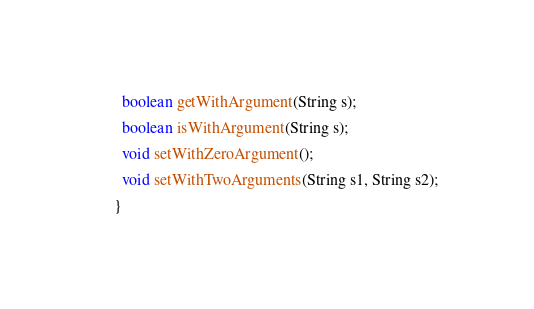<code> <loc_0><loc_0><loc_500><loc_500><_Java_>
  boolean getWithArgument(String s);

  boolean isWithArgument(String s);

  void setWithZeroArgument();

  void setWithTwoArguments(String s1, String s2);

}
</code> 